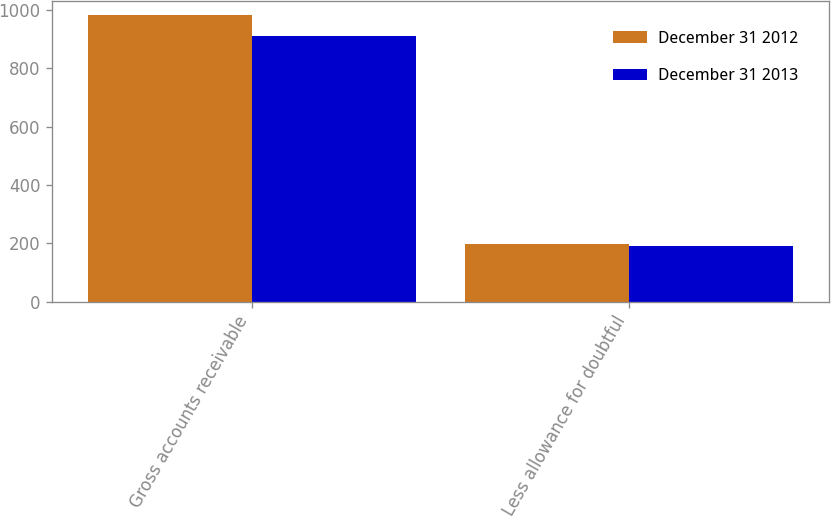Convert chart to OTSL. <chart><loc_0><loc_0><loc_500><loc_500><stacked_bar_chart><ecel><fcel>Gross accounts receivable<fcel>Less allowance for doubtful<nl><fcel>December 31 2012<fcel>983<fcel>198.3<nl><fcel>December 31 2013<fcel>910<fcel>191.5<nl></chart> 